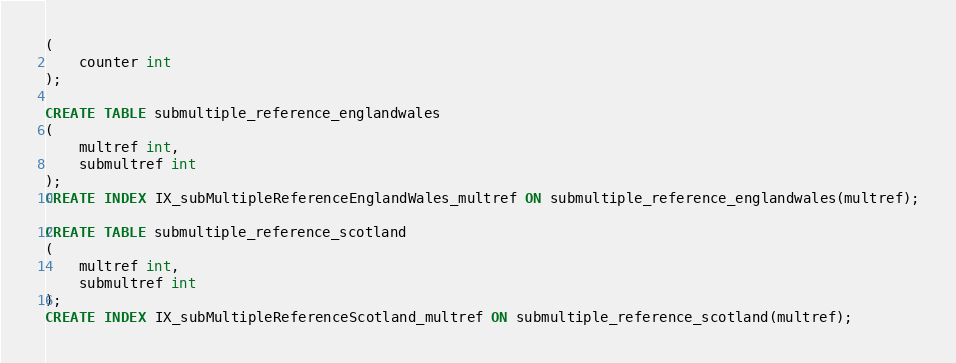<code> <loc_0><loc_0><loc_500><loc_500><_SQL_>(
    counter int
);

CREATE TABLE submultiple_reference_englandwales
(
    multref int,
    submultref int
);
CREATE INDEX IX_subMultipleReferenceEnglandWales_multref ON submultiple_reference_englandwales(multref);

CREATE TABLE submultiple_reference_scotland
(
    multref int,
    submultref int
);
CREATE INDEX IX_subMultipleReferenceScotland_multref ON submultiple_reference_scotland(multref);
</code> 